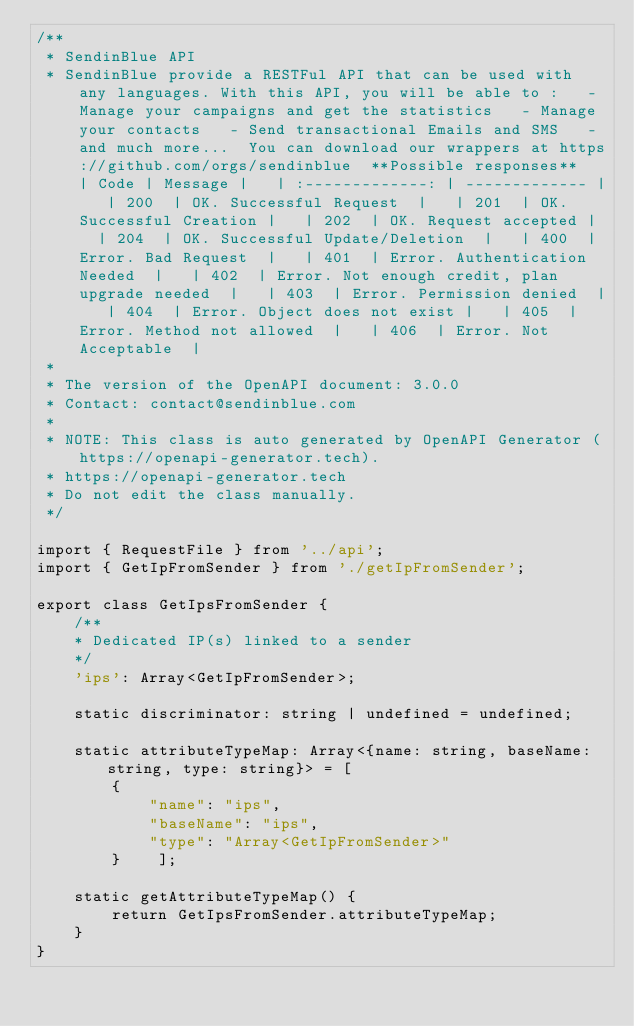Convert code to text. <code><loc_0><loc_0><loc_500><loc_500><_TypeScript_>/**
 * SendinBlue API
 * SendinBlue provide a RESTFul API that can be used with any languages. With this API, you will be able to :   - Manage your campaigns and get the statistics   - Manage your contacts   - Send transactional Emails and SMS   - and much more...  You can download our wrappers at https://github.com/orgs/sendinblue  **Possible responses**   | Code | Message |   | :-------------: | ------------- |   | 200  | OK. Successful Request  |   | 201  | OK. Successful Creation |   | 202  | OK. Request accepted |   | 204  | OK. Successful Update/Deletion  |   | 400  | Error. Bad Request  |   | 401  | Error. Authentication Needed  |   | 402  | Error. Not enough credit, plan upgrade needed  |   | 403  | Error. Permission denied  |   | 404  | Error. Object does not exist |   | 405  | Error. Method not allowed  |   | 406  | Error. Not Acceptable  | 
 *
 * The version of the OpenAPI document: 3.0.0
 * Contact: contact@sendinblue.com
 *
 * NOTE: This class is auto generated by OpenAPI Generator (https://openapi-generator.tech).
 * https://openapi-generator.tech
 * Do not edit the class manually.
 */

import { RequestFile } from '../api';
import { GetIpFromSender } from './getIpFromSender';

export class GetIpsFromSender {
    /**
    * Dedicated IP(s) linked to a sender
    */
    'ips': Array<GetIpFromSender>;

    static discriminator: string | undefined = undefined;

    static attributeTypeMap: Array<{name: string, baseName: string, type: string}> = [
        {
            "name": "ips",
            "baseName": "ips",
            "type": "Array<GetIpFromSender>"
        }    ];

    static getAttributeTypeMap() {
        return GetIpsFromSender.attributeTypeMap;
    }
}

</code> 